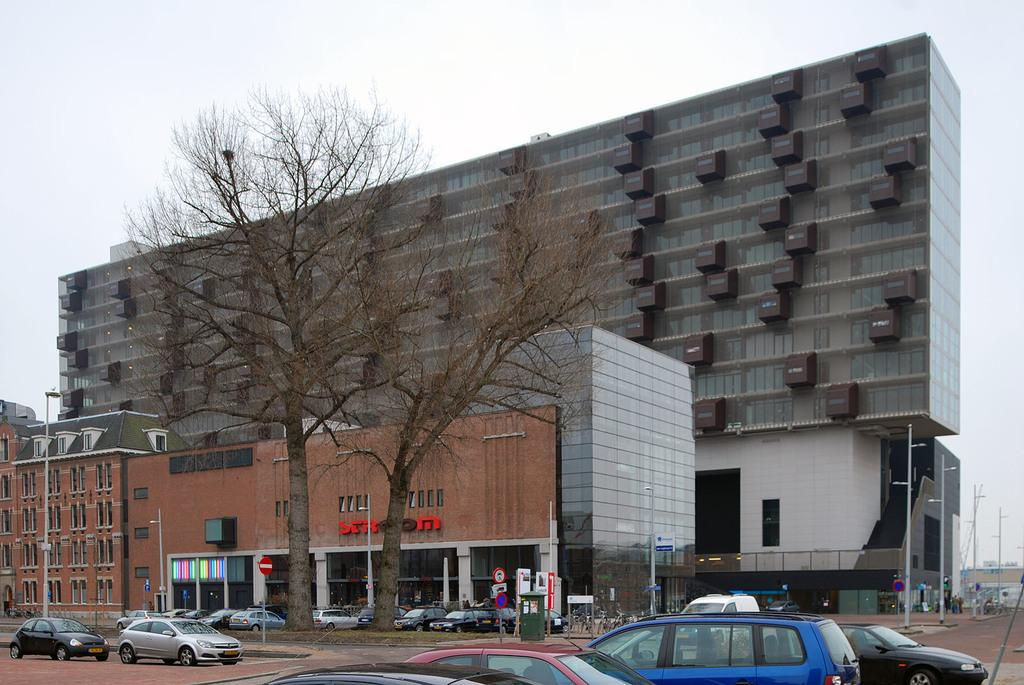What is present on the road in the image? There are vehicles on the road in the image. How can the vehicles be distinguished from one another? The vehicles are in different colors. What can be seen in the background of the image? There are poles, trees, vehicles parked, and buildings in the background. What is visible in the sky in the image? There are clouds visible in the sky. How many legs can be seen on the banana in the image? There is no banana present in the image, and therefore no legs can be seen on it. 